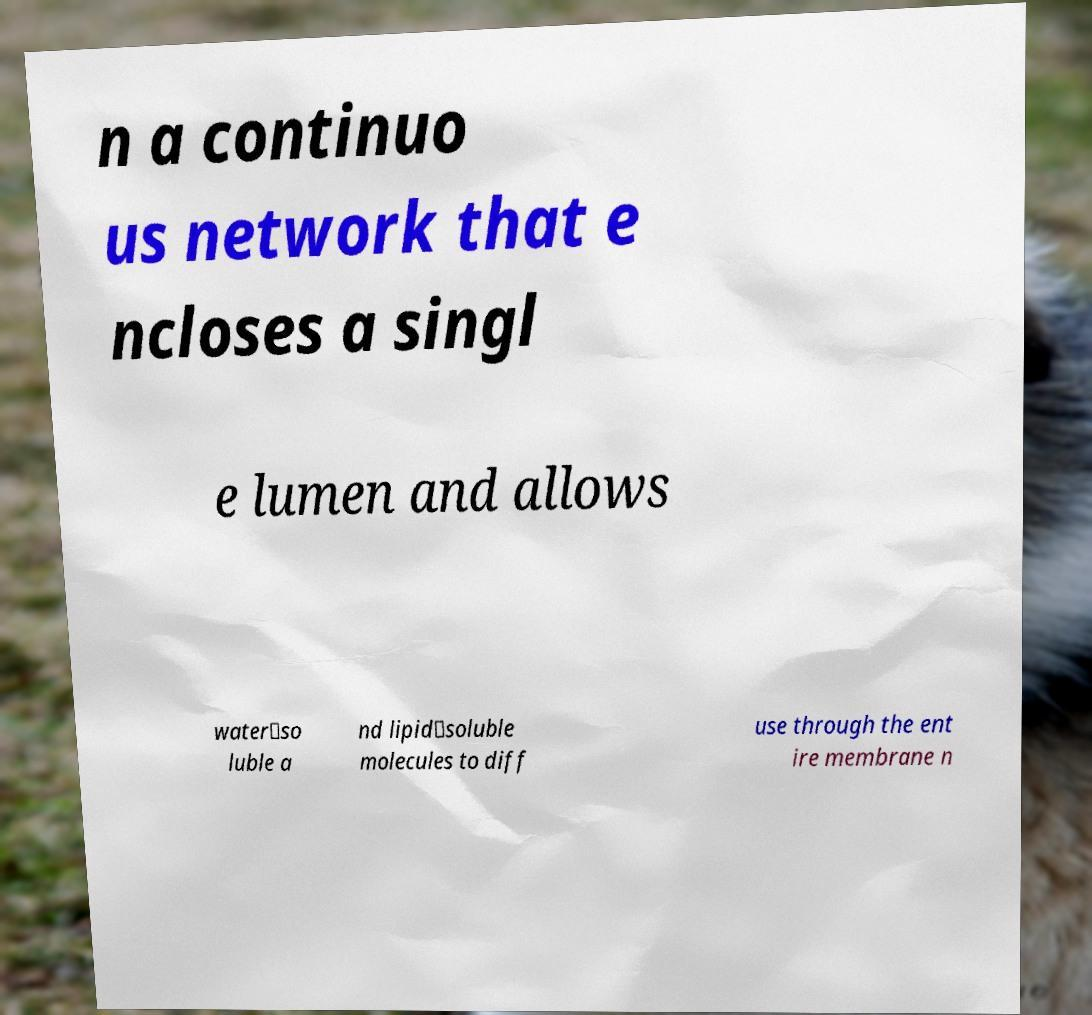Please identify and transcribe the text found in this image. n a continuo us network that e ncloses a singl e lumen and allows water‐so luble a nd lipid‐soluble molecules to diff use through the ent ire membrane n 